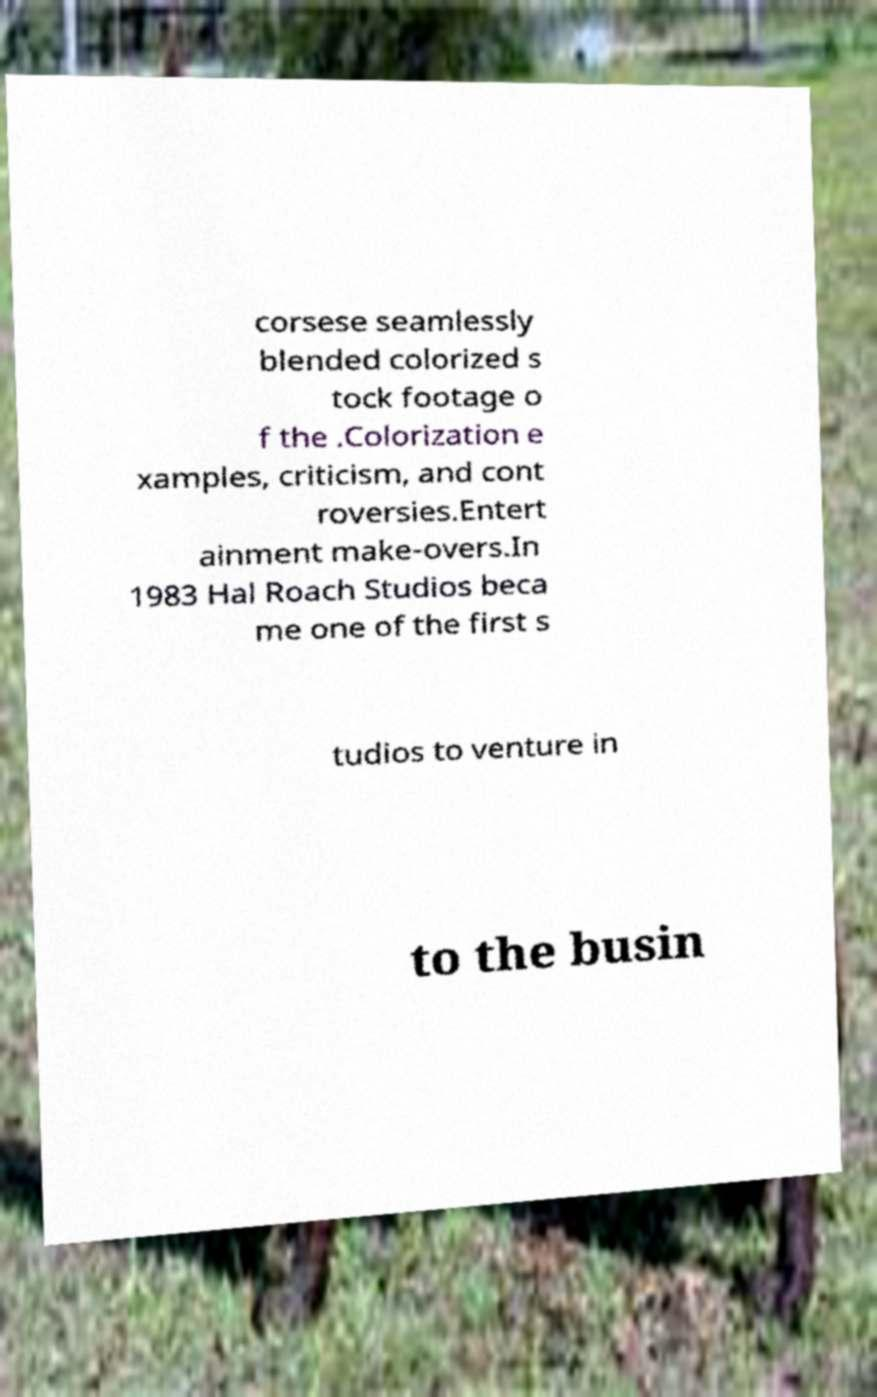There's text embedded in this image that I need extracted. Can you transcribe it verbatim? corsese seamlessly blended colorized s tock footage o f the .Colorization e xamples, criticism, and cont roversies.Entert ainment make-overs.In 1983 Hal Roach Studios beca me one of the first s tudios to venture in to the busin 